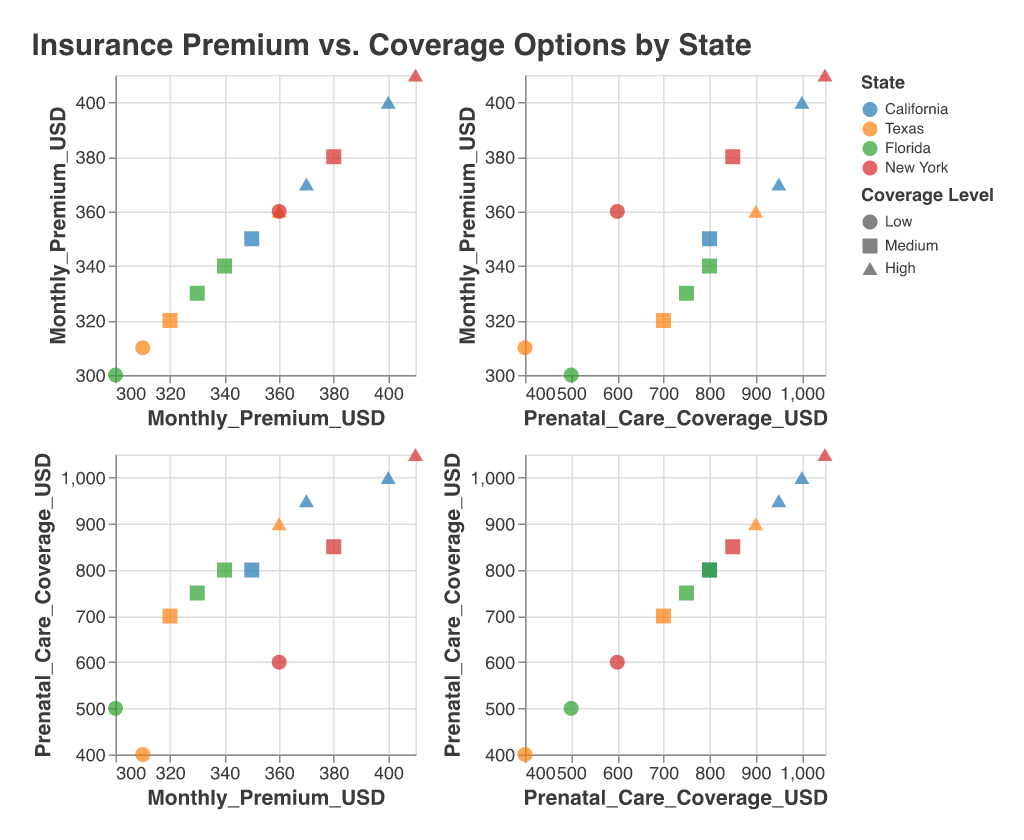How many states are represented in the scatter plot matrix? The plot shows four distinct colors representing four different states.
Answer: 4 Which state has the highest prenatal care coverage, and what is the amount? By looking at the Prenatal_Care_Coverage_USD axis, the highest value is represented by the red color, which corresponds to New York with a coverage amount of $1050.
Answer: New York, $1050 What is the monthly premium range for California? The range of Monthly_Premium_USD for California can be seen by observing the data points colored blue. The lowest premium is $350, and the highest is $400.
Answer: $350 to $400 Are there any insurance providers in Texas with a high coverage level and a monthly premium lower than $350? By focusing on the orange-colored points for Texas and filtering for "triangle-up" shapes representing high coverage levels, UnitedHealthcare with a $360 monthly premium is the closest, but no provider has high coverage under $350.
Answer: No What's the general trend between monthly premium and prenatal care coverage in this data? Observing the scatter plot matrix, there is a trend that higher monthly premiums correspond to higher prenatal care coverage. This can be seen by the upward slope in the points.
Answer: Higher premiums generally indicate higher prenatal care coverage Which state has the lowest monthly premium, what is the premium amount, and who is the provider? Looking at the Monthly_Premium_USD axis, the lowest premium is $300, represented by a green color corresponding to Florida. The provider is Molina Healthcare.
Answer: Florida, $300, Molina Healthcare How does the number of high coverage providers compare across each state? Counting the triangle-up shapes in different colors, California has 2, Texas has 1, Florida has none, and New York has 2.
Answer: California: 2, Texas: 1, Florida: 0, New York: 2 What is the difference in prenatal care coverage between Blue Shield and Cigna in California? Both providers are in California (blue points). Blue Shield provides $1000, and Cigna provides $950. The difference is $1000 - $950 = $50.
Answer: $50 Which benefit descriptions are associated with high coverage levels across all states? By examining the tooltip for triangle-up shapes (high coverage), the associated benefit descriptions are comprehensive and maternity.
Answer: Comprehensive and Maternity 